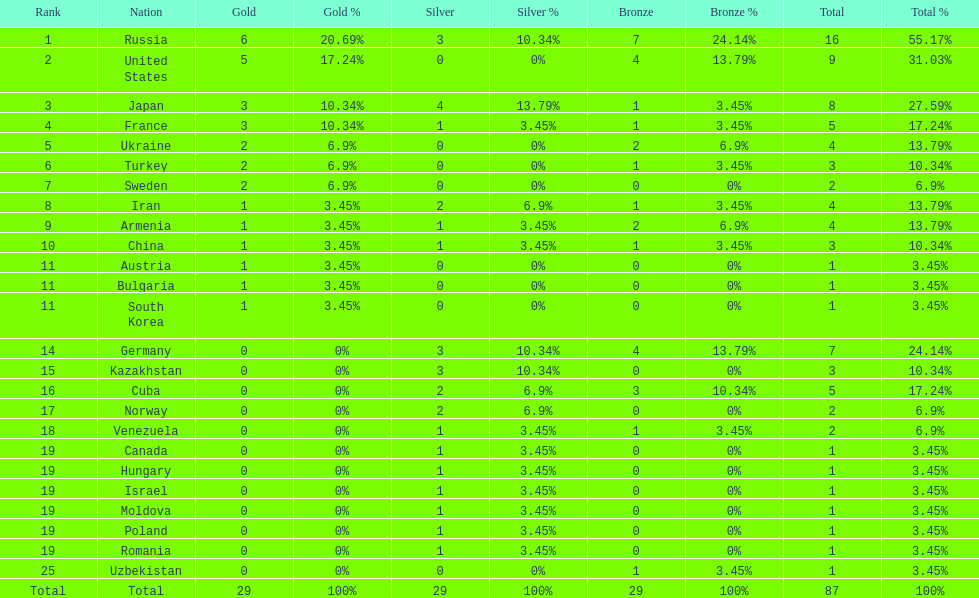Who has triumphed over the united states in terms of gold medal wins? Russia. 